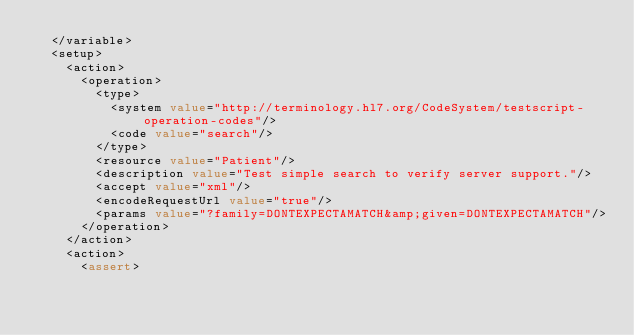<code> <loc_0><loc_0><loc_500><loc_500><_XML_>  </variable>
  <setup>
    <action>
      <operation>
        <type>
          <system value="http://terminology.hl7.org/CodeSystem/testscript-operation-codes"/>
          <code value="search"/>
        </type>
        <resource value="Patient"/>
        <description value="Test simple search to verify server support."/>
        <accept value="xml"/>
        <encodeRequestUrl value="true"/>
        <params value="?family=DONTEXPECTAMATCH&amp;given=DONTEXPECTAMATCH"/>
      </operation>
    </action>
    <action>
      <assert></code> 